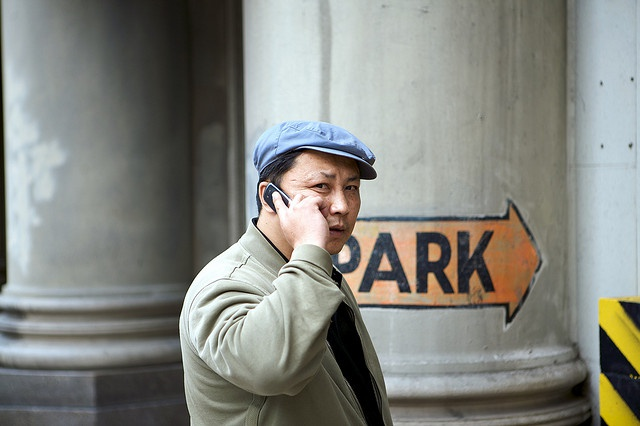Describe the objects in this image and their specific colors. I can see people in darkgreen, lightgray, black, darkgray, and gray tones and cell phone in darkgreen, black, gray, and white tones in this image. 